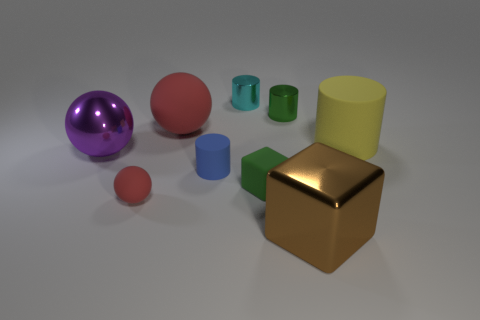Add 1 small gray cylinders. How many objects exist? 10 Subtract all cubes. How many objects are left? 7 Subtract all blue objects. Subtract all green metallic things. How many objects are left? 7 Add 8 big purple metallic spheres. How many big purple metallic spheres are left? 9 Add 2 purple rubber cylinders. How many purple rubber cylinders exist? 2 Subtract 0 gray cylinders. How many objects are left? 9 